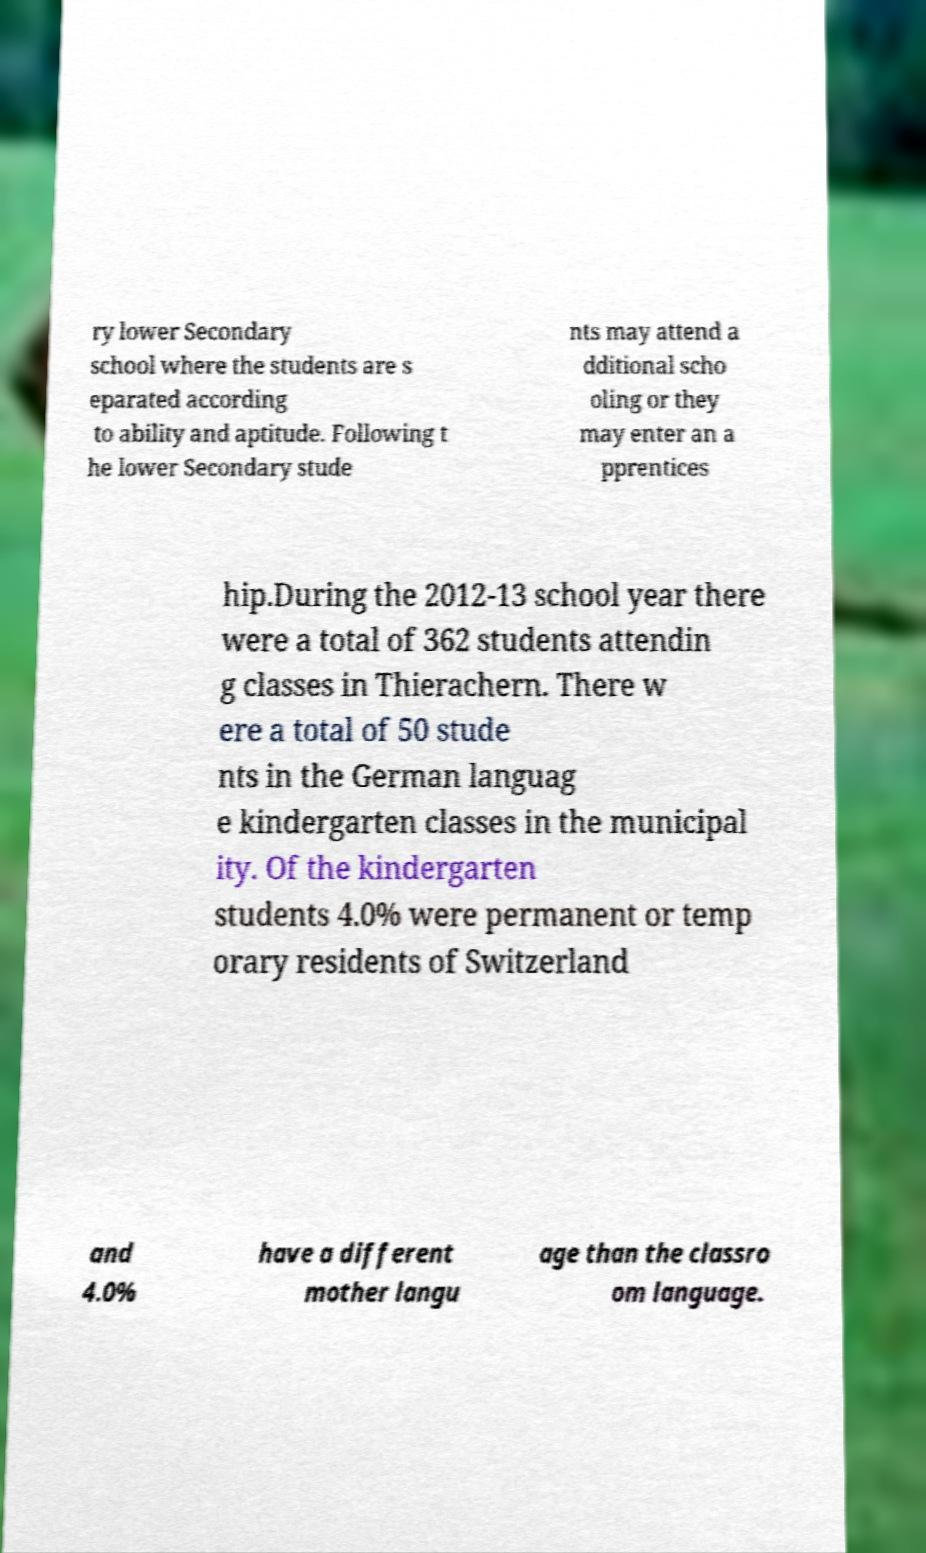For documentation purposes, I need the text within this image transcribed. Could you provide that? ry lower Secondary school where the students are s eparated according to ability and aptitude. Following t he lower Secondary stude nts may attend a dditional scho oling or they may enter an a pprentices hip.During the 2012-13 school year there were a total of 362 students attendin g classes in Thierachern. There w ere a total of 50 stude nts in the German languag e kindergarten classes in the municipal ity. Of the kindergarten students 4.0% were permanent or temp orary residents of Switzerland and 4.0% have a different mother langu age than the classro om language. 